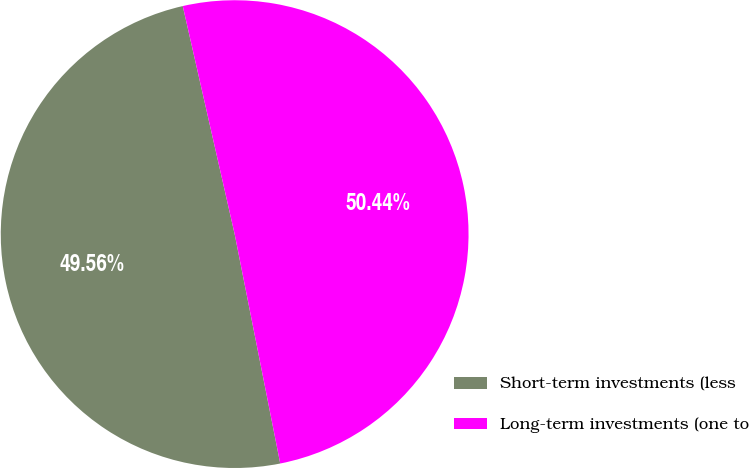<chart> <loc_0><loc_0><loc_500><loc_500><pie_chart><fcel>Short-term investments (less<fcel>Long-term investments (one to<nl><fcel>49.56%<fcel>50.44%<nl></chart> 